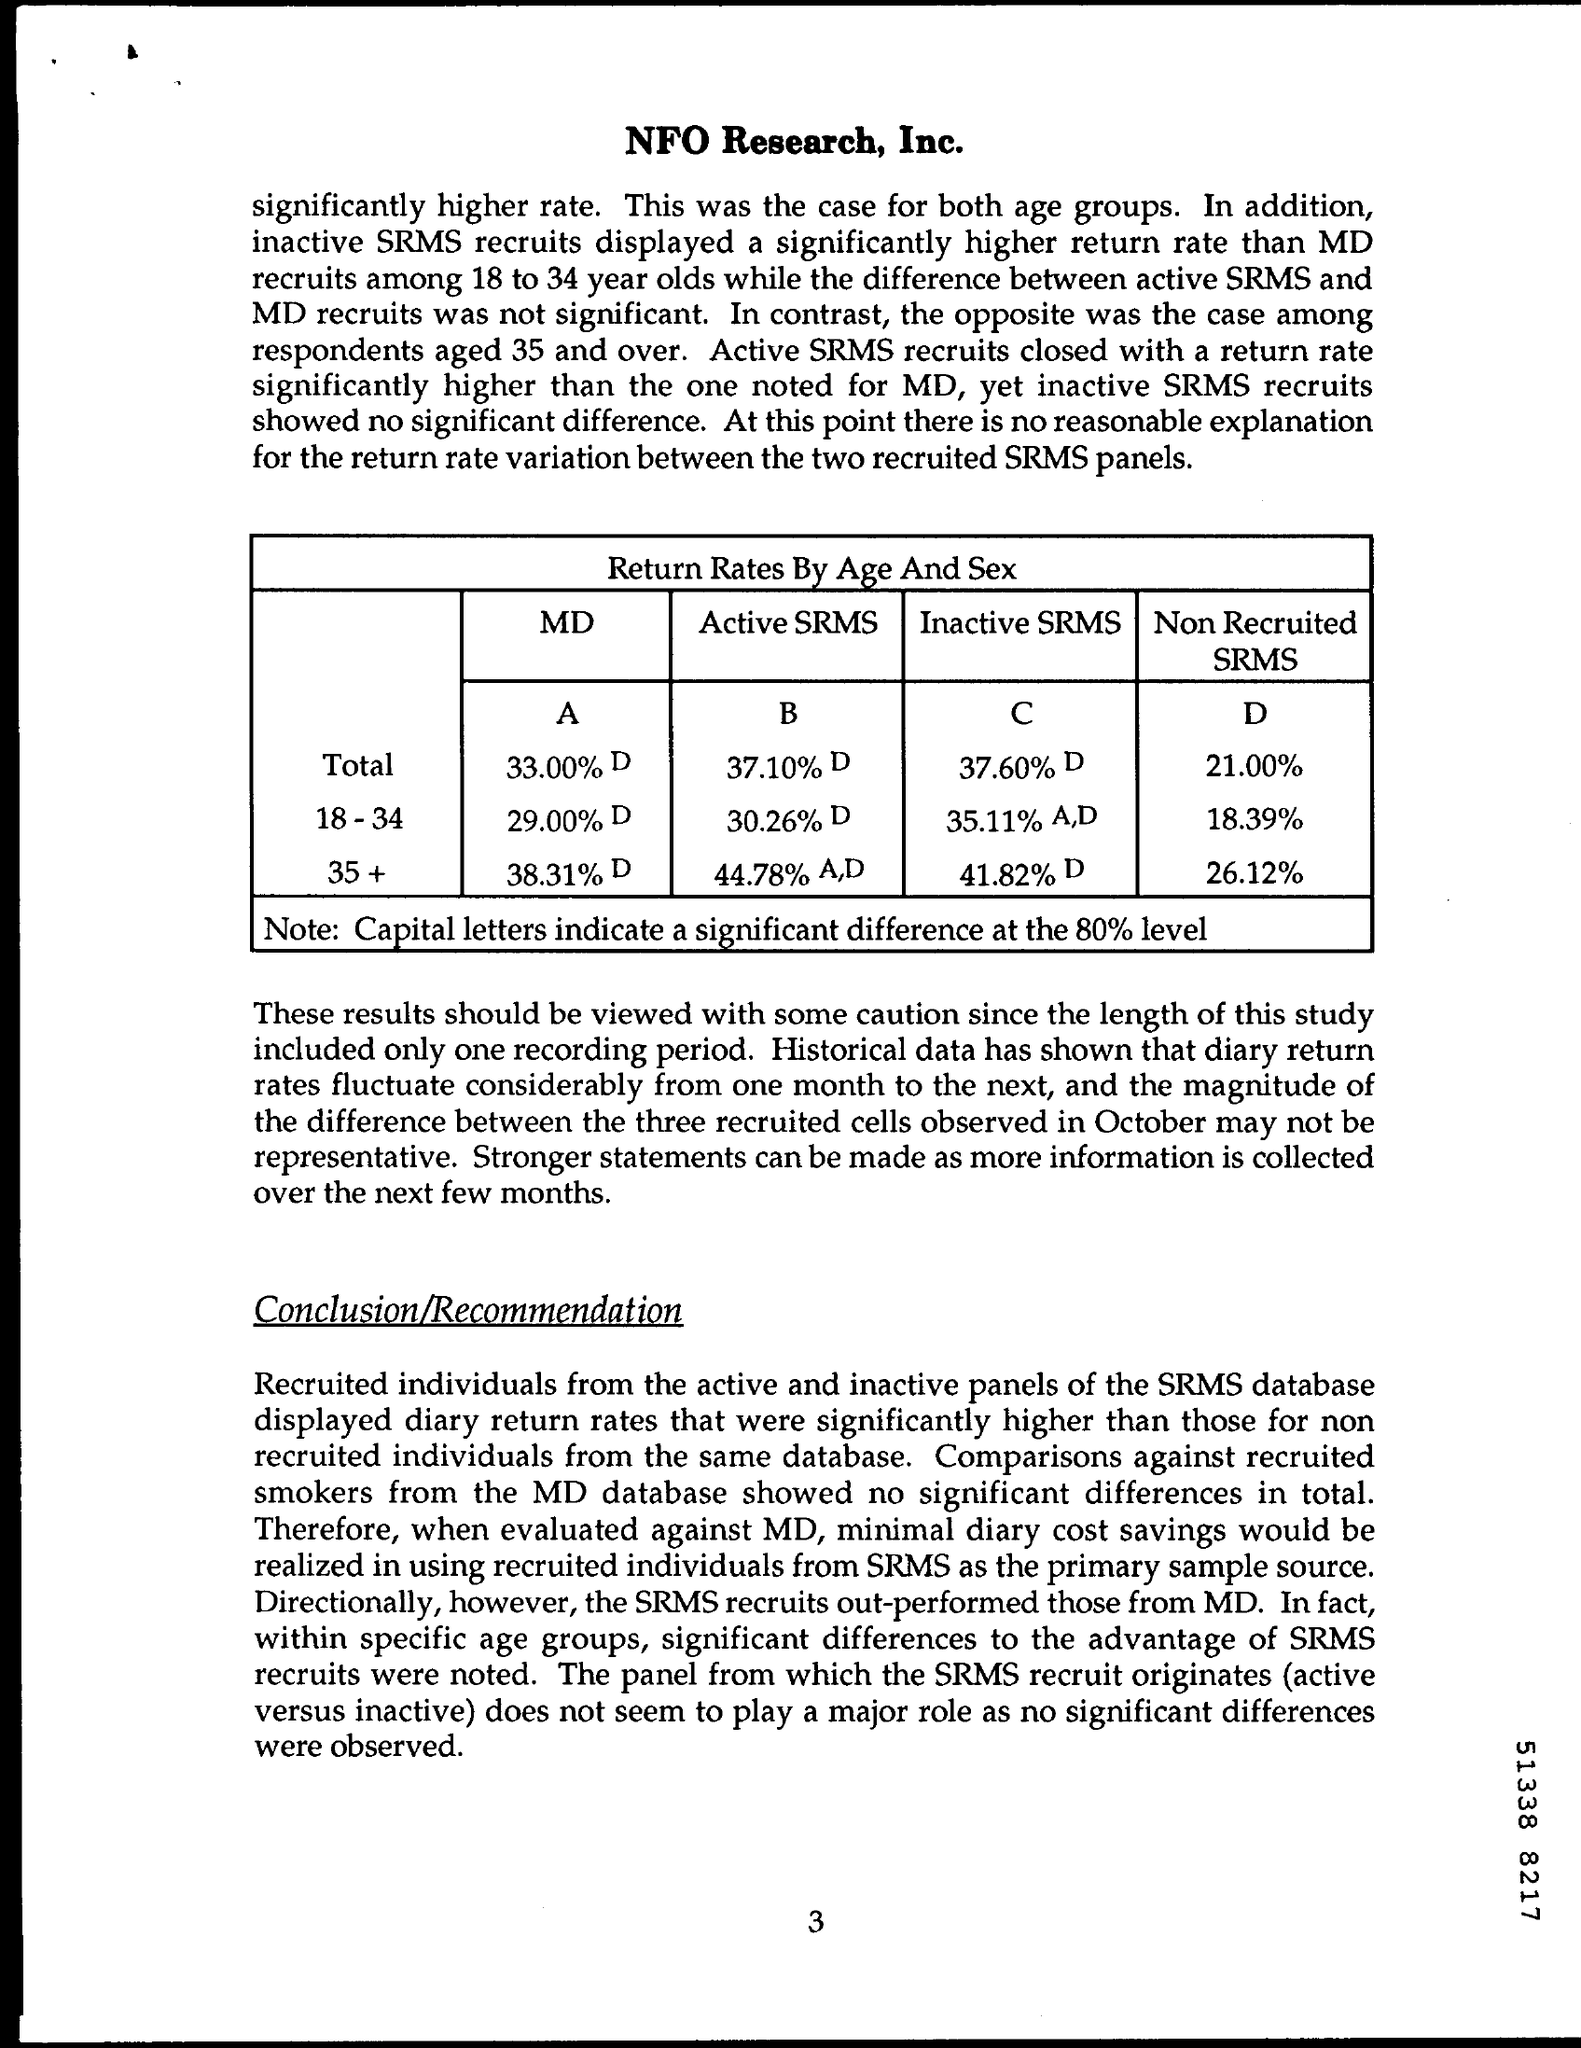Can you summarize the 'Conclusion/Recommendation' section on this page? The 'Conclusion/Recommendation' section states that individuals from the active and inactive SRMS panels displayed higher diary return rates than those not recruited from the same database, and that recruited SRMS individuals outperformed those from the MD database. Significant differences were in favor of the SRMS recruits, particularly within specific age groups, although no significant differences were noted based on whether the panel was active versus inactive. 